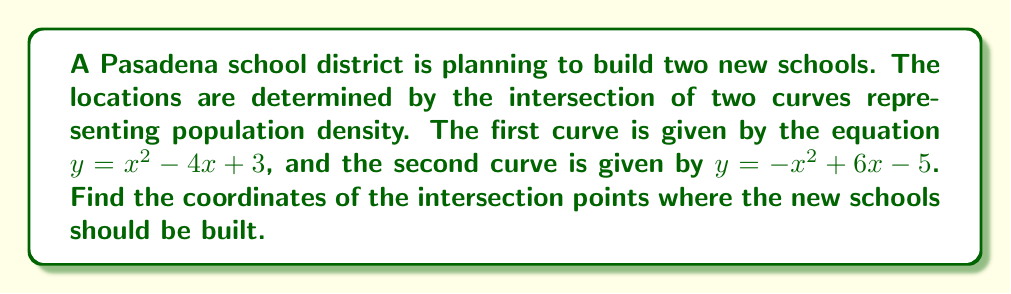Teach me how to tackle this problem. To find the intersection points of these two curves, we need to solve the system of equations:

$$\begin{cases}
y = x^2 - 4x + 3 \\
y = -x^2 + 6x - 5
\end{cases}$$

Step 1: Set the equations equal to each other since they both equal y.
$x^2 - 4x + 3 = -x^2 + 6x - 5$

Step 2: Move all terms to one side of the equation.
$2x^2 - 10x + 8 = 0$

Step 3: Divide all terms by 2 to simplify.
$x^2 - 5x + 4 = 0$

Step 4: Use the quadratic formula to solve for x.
$x = \frac{-b \pm \sqrt{b^2 - 4ac}}{2a}$, where $a=1$, $b=-5$, and $c=4$

$x = \frac{5 \pm \sqrt{25 - 16}}{2} = \frac{5 \pm 3}{2}$

$x_1 = \frac{5 + 3}{2} = 4$ and $x_2 = \frac{5 - 3}{2} = 1$

Step 5: Find the corresponding y-values by substituting these x-values into either of the original equations. Let's use $y = x^2 - 4x + 3$.

For $x_1 = 4$: $y = 4^2 - 4(4) + 3 = 16 - 16 + 3 = 3$
For $x_2 = 1$: $y = 1^2 - 4(1) + 3 = 1 - 4 + 3 = 0$

Therefore, the intersection points are (4, 3) and (1, 0).
Answer: (4, 3) and (1, 0) 